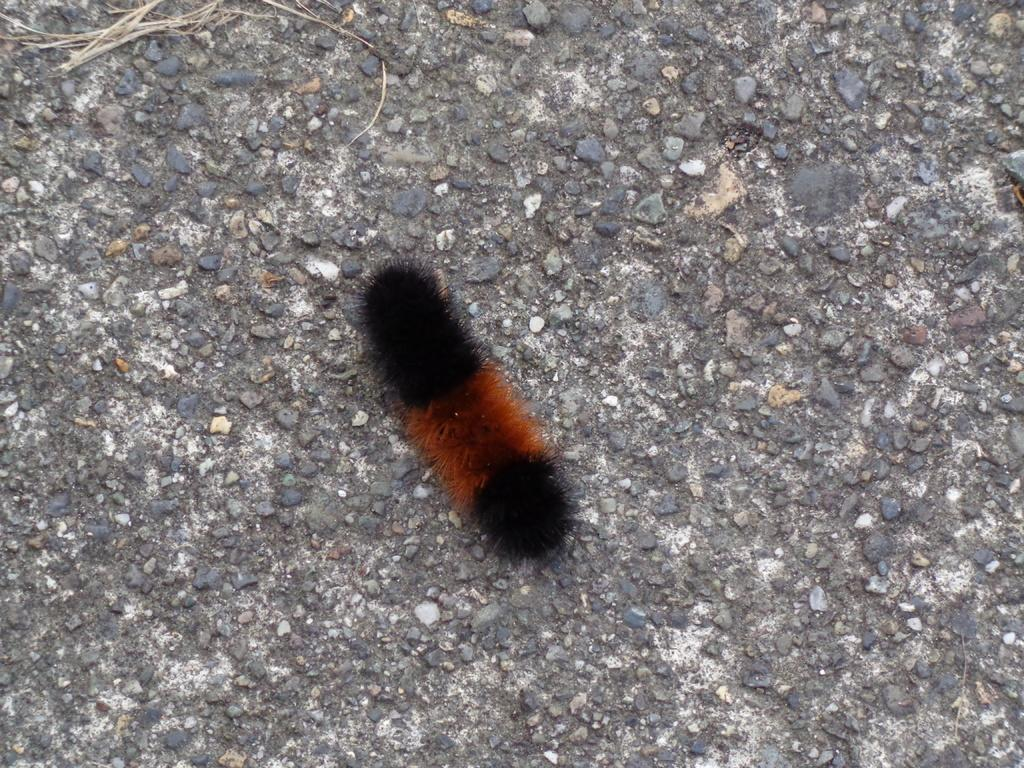What is located on the road in the image? There is a worm on the road in the image. What letter can be seen on the edge of the corn in the image? There is no corn or letter present in the image; it only features a worm on the road. 